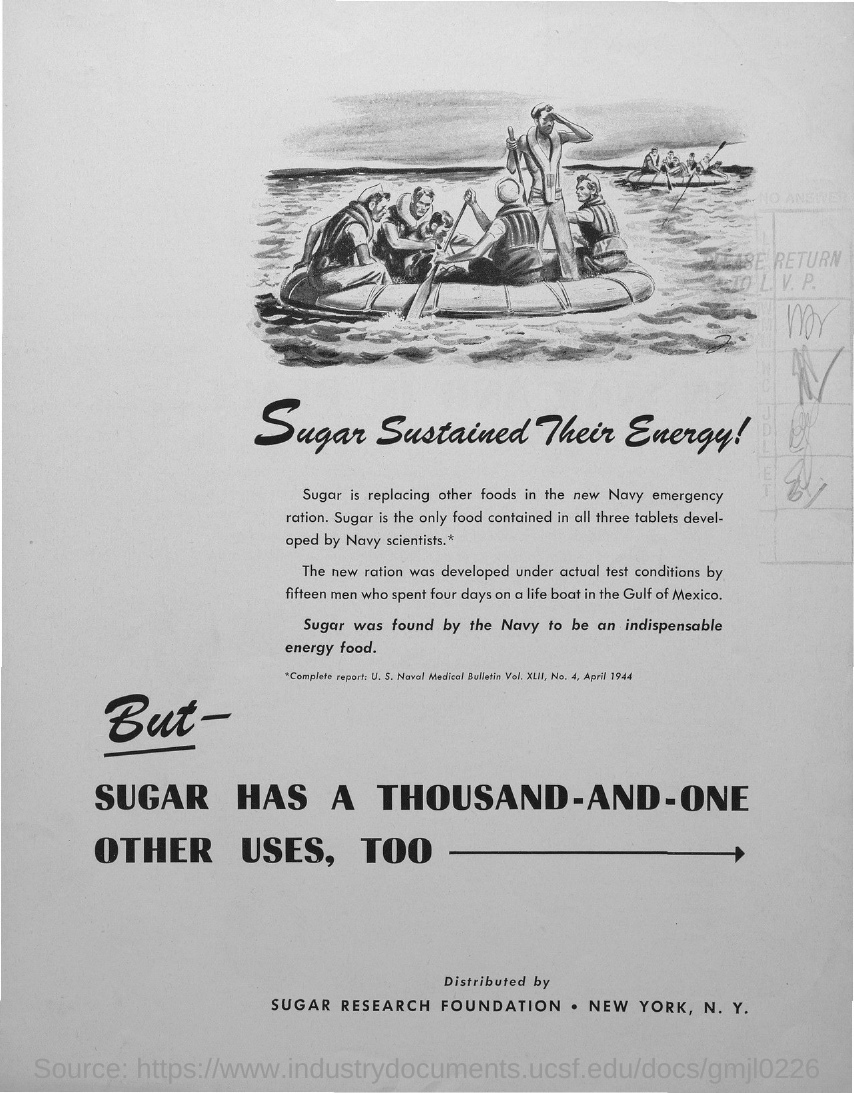Draw attention to some important aspects in this diagram. The only food found in all three tablets created by Navy scientists is sugar. 